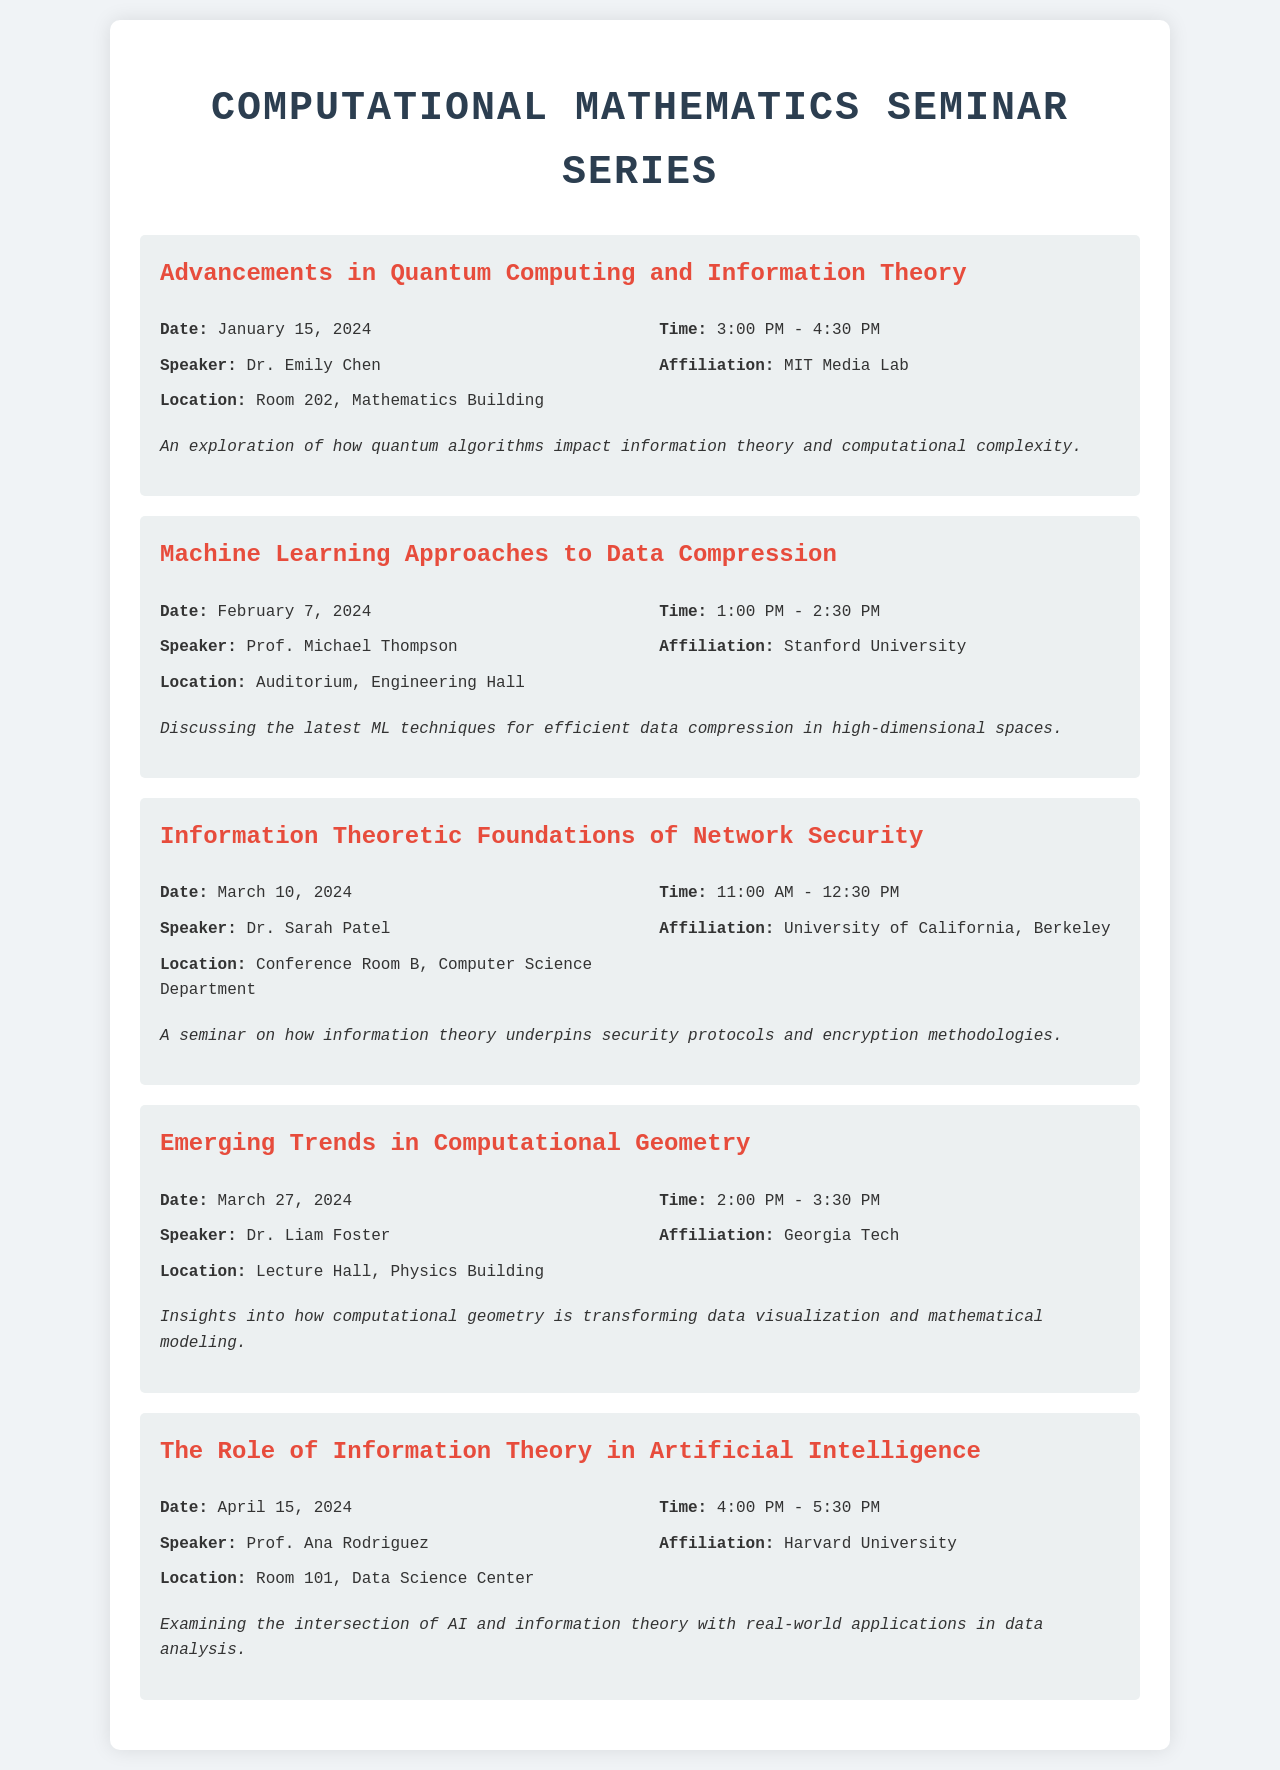What is the date of the seminar on Quantum Computing? The seminar titled "Advancements in Quantum Computing and Information Theory" is scheduled for January 15, 2024.
Answer: January 15, 2024 Who is the speaker for the data compression seminar? The seminar titled "Machine Learning Approaches to Data Compression" features Prof. Michael Thompson as the speaker.
Answer: Prof. Michael Thompson What time does the seminar on network security begin? The seminar "Information Theoretic Foundations of Network Security" starts at 11:00 AM.
Answer: 11:00 AM Which university is Dr. Sarah Patel affiliated with? Dr. Sarah Patel, the speaker for the network security seminar, is affiliated with the University of California, Berkeley.
Answer: University of California, Berkeley What is the location of the seminar on Computational Geometry? The seminar "Emerging Trends in Computational Geometry" will take place in the Lecture Hall, Physics Building.
Answer: Lecture Hall, Physics Building How many seminars are scheduled in April 2024? There is one seminar scheduled in April, specifically on April 15, 2024.
Answer: One What topic will Prof. Ana Rodriguez discuss? Prof. Ana Rodriguez will examine "The Role of Information Theory in Artificial Intelligence."
Answer: The Role of Information Theory in Artificial Intelligence What is a common theme across the seminars? The seminars frequently explore intersections of computational mathematics with other fields such as AI, data compression, and network security.
Answer: Intersections of computational mathematics with AI, data compression, and network security 